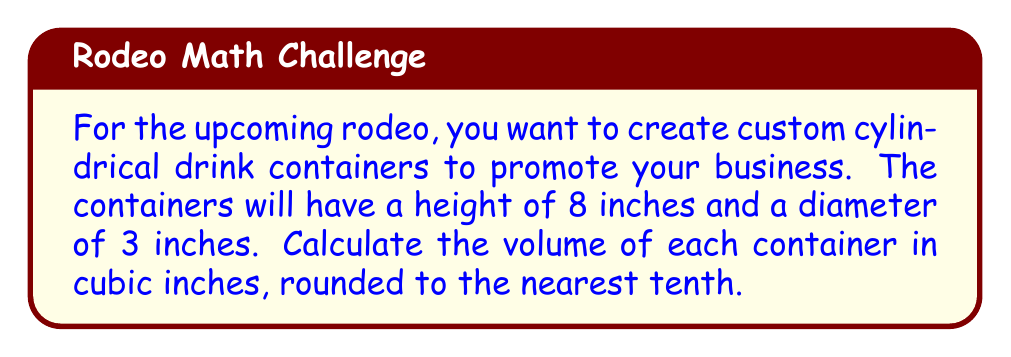Could you help me with this problem? To calculate the volume of a cylindrical container, we use the formula:

$$V = \pi r^2 h$$

Where:
$V$ = volume
$r$ = radius of the base
$h$ = height of the cylinder

Given:
- Height (h) = 8 inches
- Diameter = 3 inches

Step 1: Calculate the radius
The radius is half the diameter:
$r = \frac{3}{2} = 1.5$ inches

Step 2: Apply the volume formula
$$V = \pi (1.5)^2 (8)$$

Step 3: Calculate
$$V = \pi (2.25) (8)$$
$$V = 18\pi$$

Step 4: Evaluate and round to the nearest tenth
$$V \approx 56.5 \text{ cubic inches}$$

[asy]
import geometry;

size(100);
real r = 1.5;
real h = 8;
path3 p = circle((0,0,0), r);
draw(surface(p -- (0,0,h) -- cycle), paleblue+opacity(0.5));
draw(p);
draw((0,0,h) -- (r,0,h) -- (r,0,0));
draw((0,0,0) -- (0,0,h), dashed);
label("r", (r/2,0,0), S);
label("h", (r,0,h/2), E);
[/asy]
Answer: The volume of each cylindrical drink container is approximately 56.5 cubic inches. 